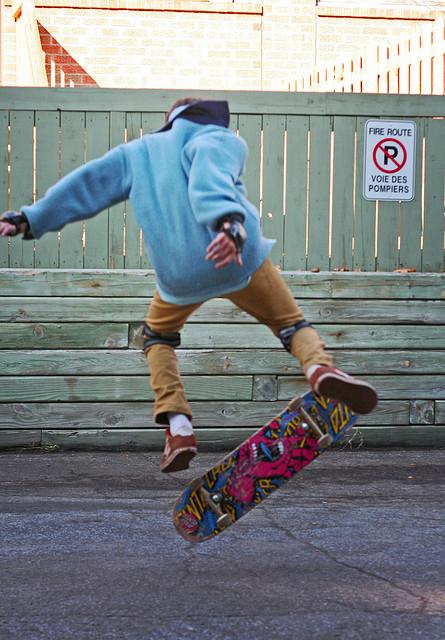How many wheels do you see?
Keep it brief. 4. Is the skater wearing knee pads?
Write a very short answer. Yes. Is it ok to park here?
Answer briefly. No. 